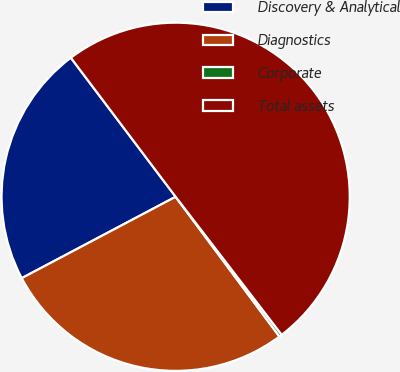Convert chart. <chart><loc_0><loc_0><loc_500><loc_500><pie_chart><fcel>Discovery & Analytical<fcel>Diagnostics<fcel>Corporate<fcel>Total assets<nl><fcel>22.46%<fcel>27.42%<fcel>0.26%<fcel>49.85%<nl></chart> 